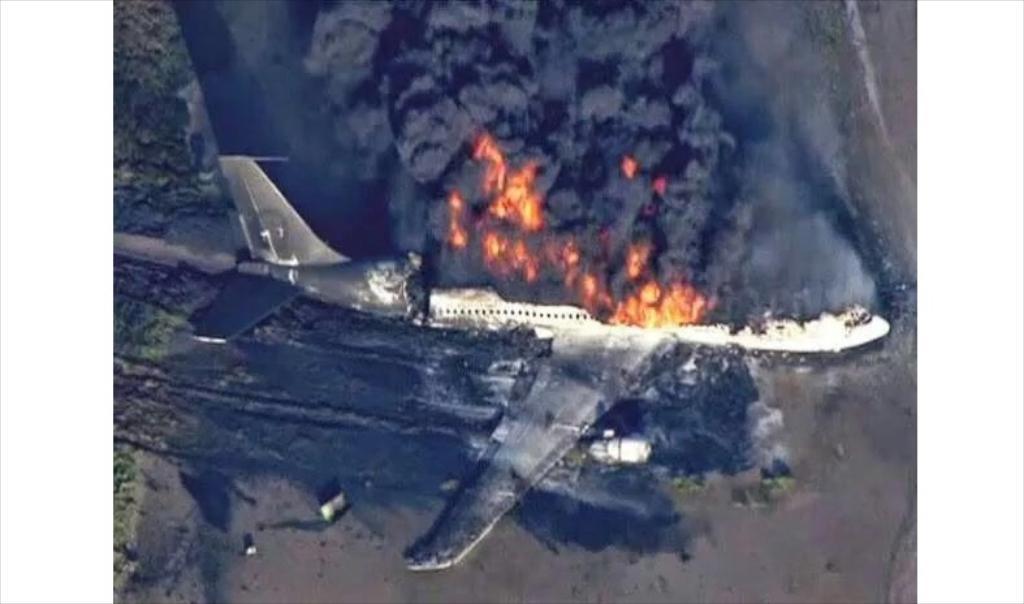Describe this image in one or two sentences. In this picture we can see a burning plane on the ground. On the top we can see the fire and smoke. 